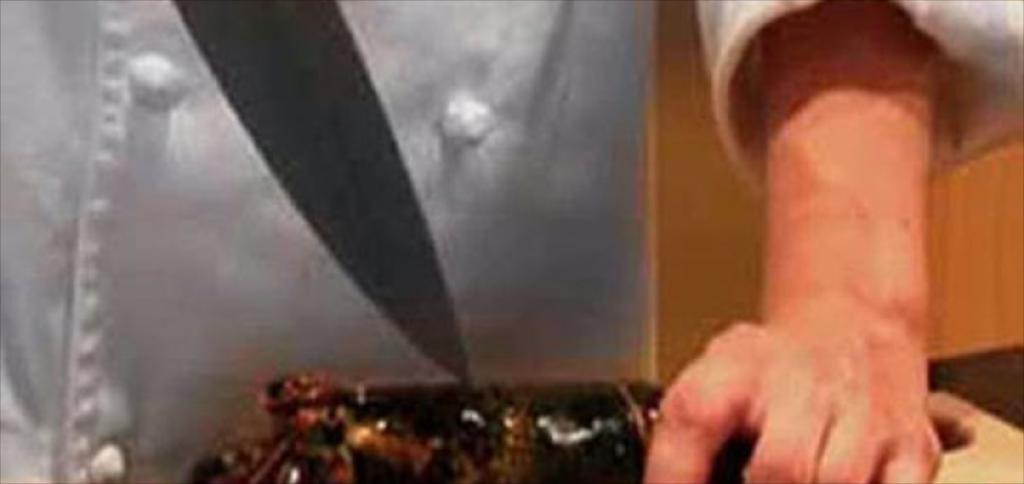Can you describe this image briefly? In this image we can see a person holding a fish which is placed on the surface. We can also see a knife. 